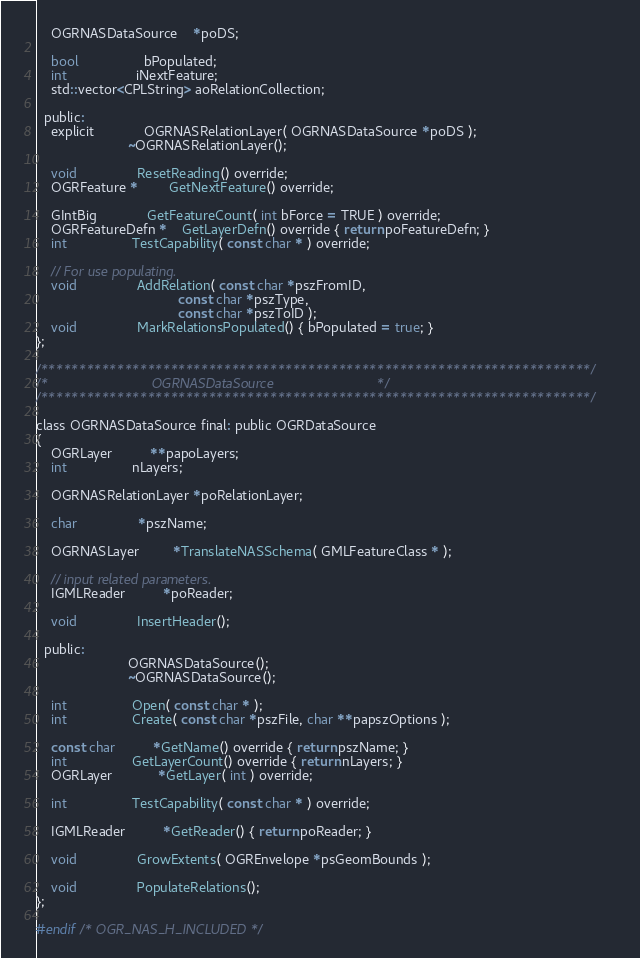<code> <loc_0><loc_0><loc_500><loc_500><_C_>    OGRNASDataSource    *poDS;

    bool                 bPopulated;
    int                  iNextFeature;
    std::vector<CPLString> aoRelationCollection;

  public:
    explicit             OGRNASRelationLayer( OGRNASDataSource *poDS );
                        ~OGRNASRelationLayer();

    void                ResetReading() override;
    OGRFeature *        GetNextFeature() override;

    GIntBig             GetFeatureCount( int bForce = TRUE ) override;
    OGRFeatureDefn *    GetLayerDefn() override { return poFeatureDefn; }
    int                 TestCapability( const char * ) override;

    // For use populating.
    void                AddRelation( const char *pszFromID,
                                     const char *pszType,
                                     const char *pszToID );
    void                MarkRelationsPopulated() { bPopulated = true; }
};

/************************************************************************/
/*                           OGRNASDataSource                           */
/************************************************************************/

class OGRNASDataSource final: public OGRDataSource
{
    OGRLayer          **papoLayers;
    int                 nLayers;

    OGRNASRelationLayer *poRelationLayer;

    char                *pszName;

    OGRNASLayer         *TranslateNASSchema( GMLFeatureClass * );

    // input related parameters.
    IGMLReader          *poReader;

    void                InsertHeader();

  public:
                        OGRNASDataSource();
                        ~OGRNASDataSource();

    int                 Open( const char * );
    int                 Create( const char *pszFile, char **papszOptions );

    const char          *GetName() override { return pszName; }
    int                 GetLayerCount() override { return nLayers; }
    OGRLayer            *GetLayer( int ) override;

    int                 TestCapability( const char * ) override;

    IGMLReader          *GetReader() { return poReader; }

    void                GrowExtents( OGREnvelope *psGeomBounds );

    void                PopulateRelations();
};

#endif /* OGR_NAS_H_INCLUDED */
</code> 